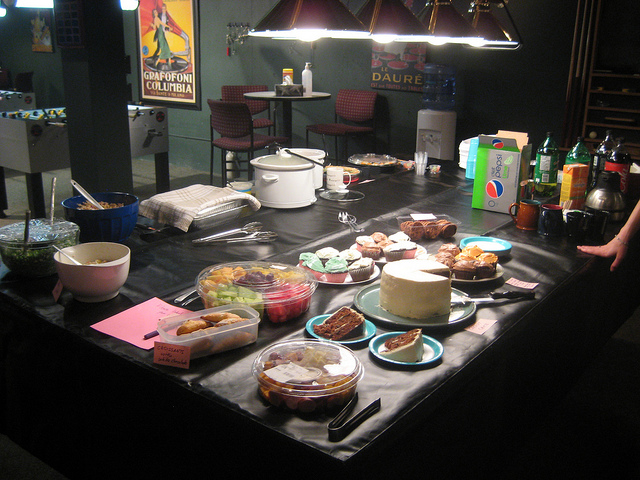Extract all visible text content from this image. GRAFOFONI COLUMBIA pepsi DAURE 